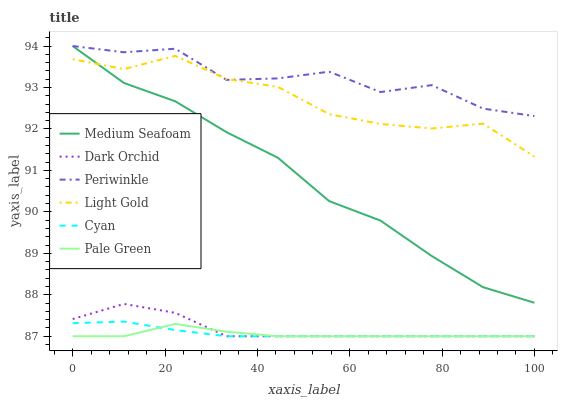Does Periwinkle have the minimum area under the curve?
Answer yes or no. No. Does Pale Green have the maximum area under the curve?
Answer yes or no. No. Is Pale Green the smoothest?
Answer yes or no. No. Is Pale Green the roughest?
Answer yes or no. No. Does Periwinkle have the lowest value?
Answer yes or no. No. Does Pale Green have the highest value?
Answer yes or no. No. Is Cyan less than Medium Seafoam?
Answer yes or no. Yes. Is Light Gold greater than Cyan?
Answer yes or no. Yes. Does Cyan intersect Medium Seafoam?
Answer yes or no. No. 